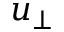Convert formula to latex. <formula><loc_0><loc_0><loc_500><loc_500>u _ { \perp }</formula> 